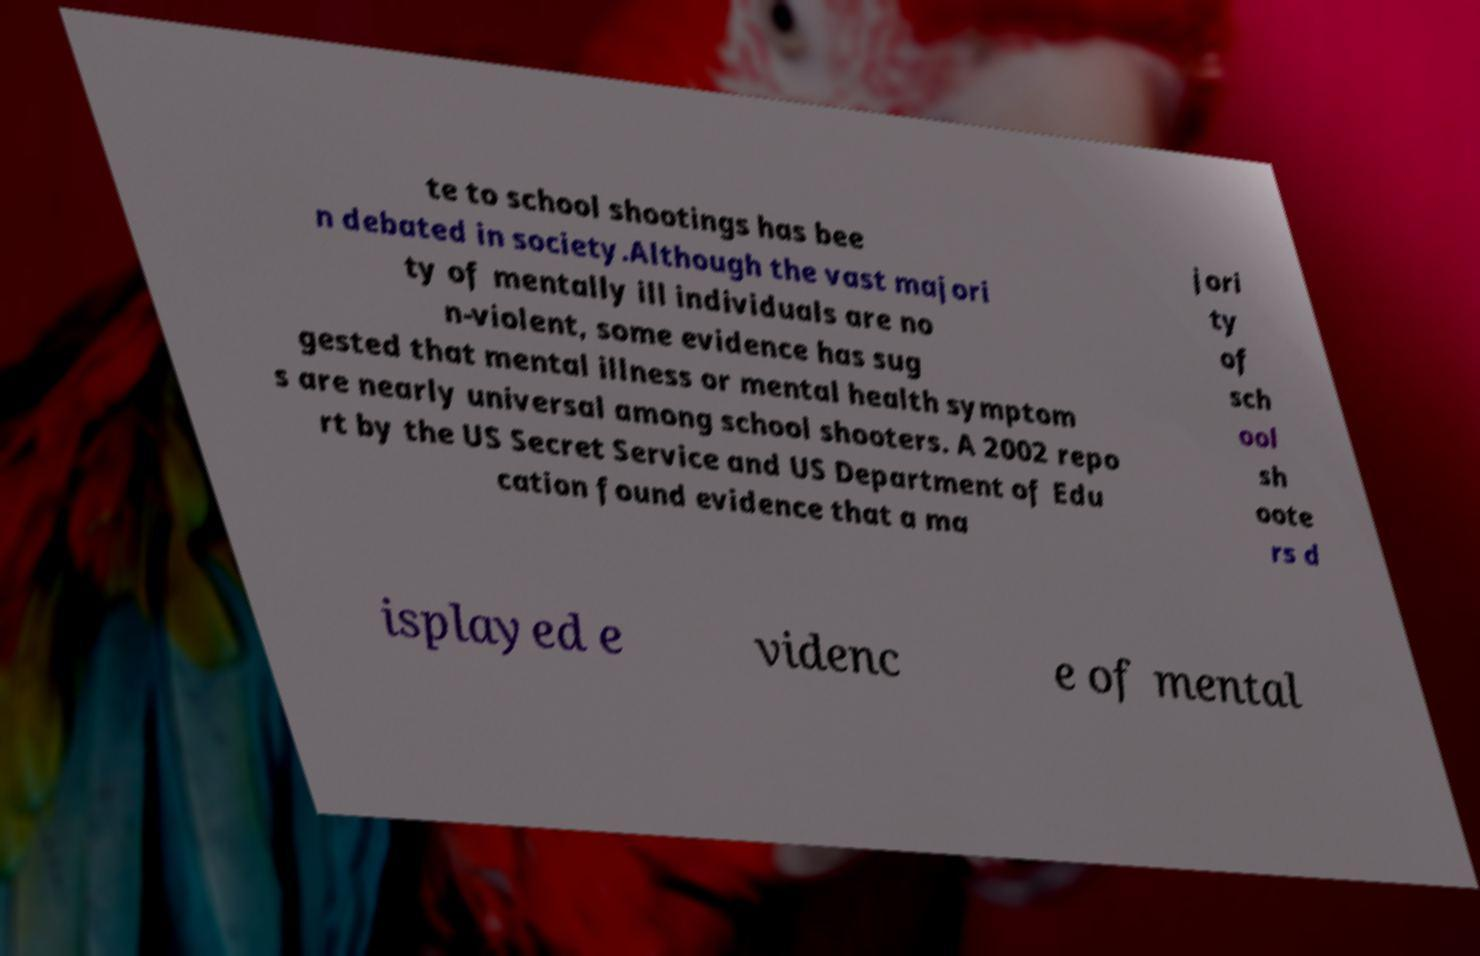What messages or text are displayed in this image? I need them in a readable, typed format. te to school shootings has bee n debated in society.Although the vast majori ty of mentally ill individuals are no n-violent, some evidence has sug gested that mental illness or mental health symptom s are nearly universal among school shooters. A 2002 repo rt by the US Secret Service and US Department of Edu cation found evidence that a ma jori ty of sch ool sh oote rs d isplayed e videnc e of mental 